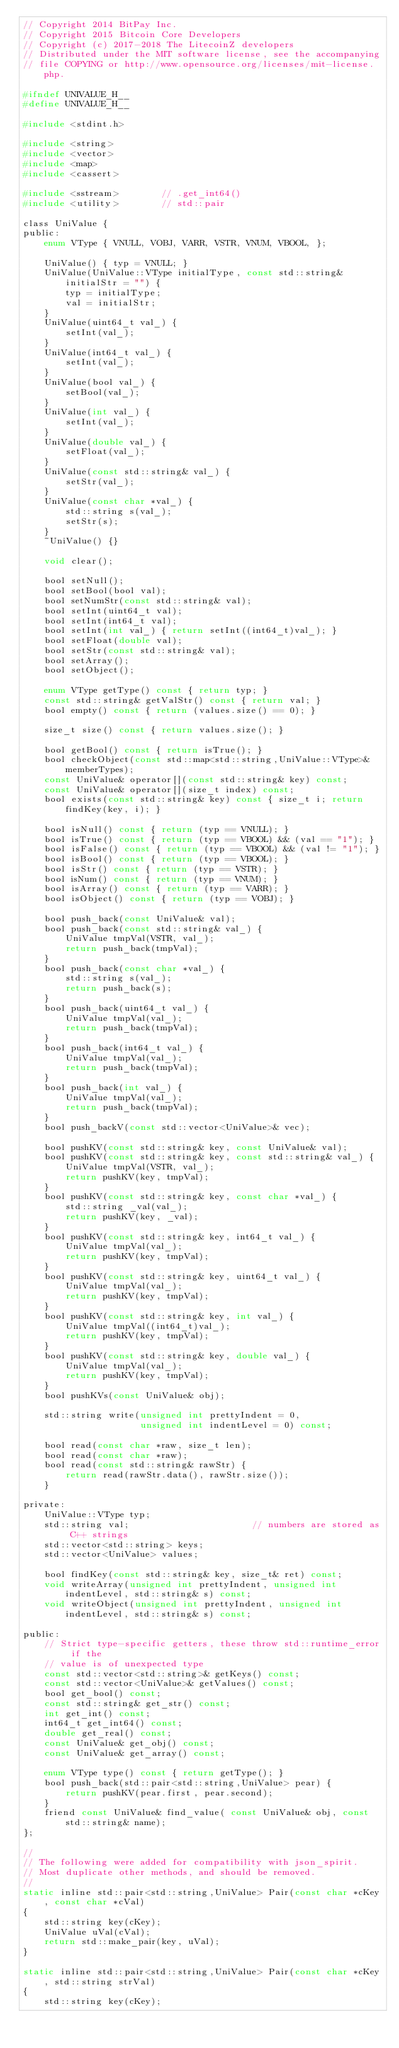<code> <loc_0><loc_0><loc_500><loc_500><_C_>// Copyright 2014 BitPay Inc.
// Copyright 2015 Bitcoin Core Developers
// Copyright (c) 2017-2018 The LitecoinZ developers
// Distributed under the MIT software license, see the accompanying
// file COPYING or http://www.opensource.org/licenses/mit-license.php.

#ifndef UNIVALUE_H__
#define UNIVALUE_H__

#include <stdint.h>

#include <string>
#include <vector>
#include <map>
#include <cassert>

#include <sstream>        // .get_int64()
#include <utility>        // std::pair

class UniValue {
public:
    enum VType { VNULL, VOBJ, VARR, VSTR, VNUM, VBOOL, };

    UniValue() { typ = VNULL; }
    UniValue(UniValue::VType initialType, const std::string& initialStr = "") {
        typ = initialType;
        val = initialStr;
    }
    UniValue(uint64_t val_) {
        setInt(val_);
    }
    UniValue(int64_t val_) {
        setInt(val_);
    }
    UniValue(bool val_) {
        setBool(val_);
    }
    UniValue(int val_) {
        setInt(val_);
    }
    UniValue(double val_) {
        setFloat(val_);
    }
    UniValue(const std::string& val_) {
        setStr(val_);
    }
    UniValue(const char *val_) {
        std::string s(val_);
        setStr(s);
    }
    ~UniValue() {}

    void clear();

    bool setNull();
    bool setBool(bool val);
    bool setNumStr(const std::string& val);
    bool setInt(uint64_t val);
    bool setInt(int64_t val);
    bool setInt(int val_) { return setInt((int64_t)val_); }
    bool setFloat(double val);
    bool setStr(const std::string& val);
    bool setArray();
    bool setObject();

    enum VType getType() const { return typ; }
    const std::string& getValStr() const { return val; }
    bool empty() const { return (values.size() == 0); }

    size_t size() const { return values.size(); }

    bool getBool() const { return isTrue(); }
    bool checkObject(const std::map<std::string,UniValue::VType>& memberTypes);
    const UniValue& operator[](const std::string& key) const;
    const UniValue& operator[](size_t index) const;
    bool exists(const std::string& key) const { size_t i; return findKey(key, i); }

    bool isNull() const { return (typ == VNULL); }
    bool isTrue() const { return (typ == VBOOL) && (val == "1"); }
    bool isFalse() const { return (typ == VBOOL) && (val != "1"); }
    bool isBool() const { return (typ == VBOOL); }
    bool isStr() const { return (typ == VSTR); }
    bool isNum() const { return (typ == VNUM); }
    bool isArray() const { return (typ == VARR); }
    bool isObject() const { return (typ == VOBJ); }

    bool push_back(const UniValue& val);
    bool push_back(const std::string& val_) {
        UniValue tmpVal(VSTR, val_);
        return push_back(tmpVal);
    }
    bool push_back(const char *val_) {
        std::string s(val_);
        return push_back(s);
    }
    bool push_back(uint64_t val_) {
        UniValue tmpVal(val_);
        return push_back(tmpVal);
    }
    bool push_back(int64_t val_) {
        UniValue tmpVal(val_);
        return push_back(tmpVal);
    }
    bool push_back(int val_) {
        UniValue tmpVal(val_);
        return push_back(tmpVal);
    }
    bool push_backV(const std::vector<UniValue>& vec);

    bool pushKV(const std::string& key, const UniValue& val);
    bool pushKV(const std::string& key, const std::string& val_) {
        UniValue tmpVal(VSTR, val_);
        return pushKV(key, tmpVal);
    }
    bool pushKV(const std::string& key, const char *val_) {
        std::string _val(val_);
        return pushKV(key, _val);
    }
    bool pushKV(const std::string& key, int64_t val_) {
        UniValue tmpVal(val_);
        return pushKV(key, tmpVal);
    }
    bool pushKV(const std::string& key, uint64_t val_) {
        UniValue tmpVal(val_);
        return pushKV(key, tmpVal);
    }
    bool pushKV(const std::string& key, int val_) {
        UniValue tmpVal((int64_t)val_);
        return pushKV(key, tmpVal);
    }
    bool pushKV(const std::string& key, double val_) {
        UniValue tmpVal(val_);
        return pushKV(key, tmpVal);
    }
    bool pushKVs(const UniValue& obj);

    std::string write(unsigned int prettyIndent = 0,
                      unsigned int indentLevel = 0) const;

    bool read(const char *raw, size_t len);
    bool read(const char *raw);
    bool read(const std::string& rawStr) {
        return read(rawStr.data(), rawStr.size());
    }

private:
    UniValue::VType typ;
    std::string val;                       // numbers are stored as C++ strings
    std::vector<std::string> keys;
    std::vector<UniValue> values;

    bool findKey(const std::string& key, size_t& ret) const;
    void writeArray(unsigned int prettyIndent, unsigned int indentLevel, std::string& s) const;
    void writeObject(unsigned int prettyIndent, unsigned int indentLevel, std::string& s) const;

public:
    // Strict type-specific getters, these throw std::runtime_error if the
    // value is of unexpected type
    const std::vector<std::string>& getKeys() const;
    const std::vector<UniValue>& getValues() const;
    bool get_bool() const;
    const std::string& get_str() const;
    int get_int() const;
    int64_t get_int64() const;
    double get_real() const;
    const UniValue& get_obj() const;
    const UniValue& get_array() const;

    enum VType type() const { return getType(); }
    bool push_back(std::pair<std::string,UniValue> pear) {
        return pushKV(pear.first, pear.second);
    }
    friend const UniValue& find_value( const UniValue& obj, const std::string& name);
};

//
// The following were added for compatibility with json_spirit.
// Most duplicate other methods, and should be removed.
//
static inline std::pair<std::string,UniValue> Pair(const char *cKey, const char *cVal)
{
    std::string key(cKey);
    UniValue uVal(cVal);
    return std::make_pair(key, uVal);
}

static inline std::pair<std::string,UniValue> Pair(const char *cKey, std::string strVal)
{
    std::string key(cKey);</code> 